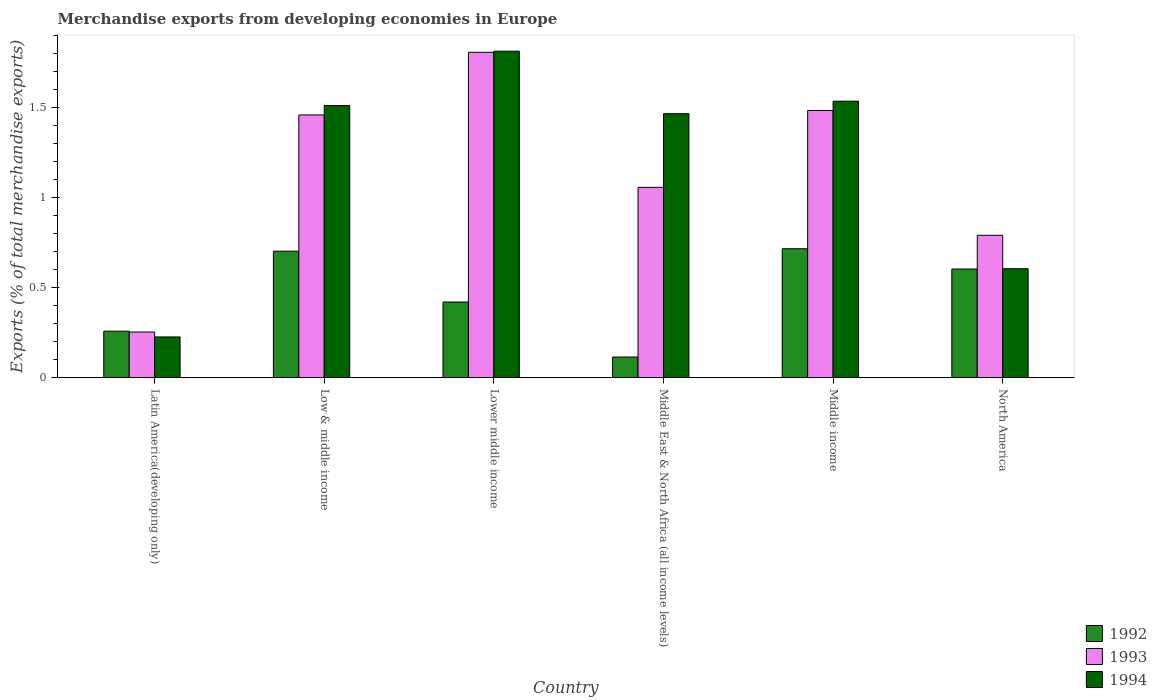How many groups of bars are there?
Keep it short and to the point. 6. Are the number of bars per tick equal to the number of legend labels?
Ensure brevity in your answer.  Yes. How many bars are there on the 2nd tick from the left?
Your answer should be very brief. 3. How many bars are there on the 6th tick from the right?
Your answer should be very brief. 3. What is the label of the 2nd group of bars from the left?
Provide a succinct answer. Low & middle income. In how many cases, is the number of bars for a given country not equal to the number of legend labels?
Offer a very short reply. 0. What is the percentage of total merchandise exports in 1992 in Middle East & North Africa (all income levels)?
Offer a terse response. 0.11. Across all countries, what is the maximum percentage of total merchandise exports in 1994?
Give a very brief answer. 1.81. Across all countries, what is the minimum percentage of total merchandise exports in 1992?
Your answer should be very brief. 0.11. In which country was the percentage of total merchandise exports in 1994 maximum?
Your answer should be compact. Lower middle income. In which country was the percentage of total merchandise exports in 1993 minimum?
Keep it short and to the point. Latin America(developing only). What is the total percentage of total merchandise exports in 1992 in the graph?
Provide a short and direct response. 2.82. What is the difference between the percentage of total merchandise exports in 1992 in Latin America(developing only) and that in Lower middle income?
Provide a succinct answer. -0.16. What is the difference between the percentage of total merchandise exports in 1994 in North America and the percentage of total merchandise exports in 1993 in Lower middle income?
Offer a terse response. -1.2. What is the average percentage of total merchandise exports in 1994 per country?
Your answer should be very brief. 1.19. What is the difference between the percentage of total merchandise exports of/in 1994 and percentage of total merchandise exports of/in 1993 in Latin America(developing only)?
Ensure brevity in your answer.  -0.03. What is the ratio of the percentage of total merchandise exports in 1993 in Low & middle income to that in Middle income?
Ensure brevity in your answer.  0.98. Is the percentage of total merchandise exports in 1993 in Latin America(developing only) less than that in North America?
Offer a terse response. Yes. What is the difference between the highest and the second highest percentage of total merchandise exports in 1992?
Provide a succinct answer. 0.01. What is the difference between the highest and the lowest percentage of total merchandise exports in 1994?
Keep it short and to the point. 1.59. In how many countries, is the percentage of total merchandise exports in 1993 greater than the average percentage of total merchandise exports in 1993 taken over all countries?
Offer a terse response. 3. What does the 1st bar from the right in Low & middle income represents?
Your answer should be compact. 1994. Is it the case that in every country, the sum of the percentage of total merchandise exports in 1994 and percentage of total merchandise exports in 1992 is greater than the percentage of total merchandise exports in 1993?
Your response must be concise. Yes. What is the difference between two consecutive major ticks on the Y-axis?
Your answer should be compact. 0.5. Are the values on the major ticks of Y-axis written in scientific E-notation?
Offer a terse response. No. Does the graph contain any zero values?
Make the answer very short. No. Does the graph contain grids?
Ensure brevity in your answer.  No. How many legend labels are there?
Give a very brief answer. 3. How are the legend labels stacked?
Ensure brevity in your answer.  Vertical. What is the title of the graph?
Give a very brief answer. Merchandise exports from developing economies in Europe. Does "2000" appear as one of the legend labels in the graph?
Give a very brief answer. No. What is the label or title of the Y-axis?
Offer a terse response. Exports (% of total merchandise exports). What is the Exports (% of total merchandise exports) of 1992 in Latin America(developing only)?
Your answer should be very brief. 0.26. What is the Exports (% of total merchandise exports) of 1993 in Latin America(developing only)?
Keep it short and to the point. 0.25. What is the Exports (% of total merchandise exports) in 1994 in Latin America(developing only)?
Your answer should be very brief. 0.23. What is the Exports (% of total merchandise exports) in 1992 in Low & middle income?
Make the answer very short. 0.7. What is the Exports (% of total merchandise exports) of 1993 in Low & middle income?
Provide a short and direct response. 1.46. What is the Exports (% of total merchandise exports) in 1994 in Low & middle income?
Your response must be concise. 1.51. What is the Exports (% of total merchandise exports) of 1992 in Lower middle income?
Offer a very short reply. 0.42. What is the Exports (% of total merchandise exports) in 1993 in Lower middle income?
Ensure brevity in your answer.  1.81. What is the Exports (% of total merchandise exports) in 1994 in Lower middle income?
Offer a terse response. 1.81. What is the Exports (% of total merchandise exports) in 1992 in Middle East & North Africa (all income levels)?
Ensure brevity in your answer.  0.11. What is the Exports (% of total merchandise exports) in 1993 in Middle East & North Africa (all income levels)?
Offer a terse response. 1.06. What is the Exports (% of total merchandise exports) in 1994 in Middle East & North Africa (all income levels)?
Give a very brief answer. 1.47. What is the Exports (% of total merchandise exports) of 1992 in Middle income?
Your response must be concise. 0.72. What is the Exports (% of total merchandise exports) in 1993 in Middle income?
Keep it short and to the point. 1.48. What is the Exports (% of total merchandise exports) in 1994 in Middle income?
Offer a terse response. 1.54. What is the Exports (% of total merchandise exports) of 1992 in North America?
Ensure brevity in your answer.  0.6. What is the Exports (% of total merchandise exports) in 1993 in North America?
Ensure brevity in your answer.  0.79. What is the Exports (% of total merchandise exports) in 1994 in North America?
Make the answer very short. 0.61. Across all countries, what is the maximum Exports (% of total merchandise exports) of 1992?
Your response must be concise. 0.72. Across all countries, what is the maximum Exports (% of total merchandise exports) of 1993?
Keep it short and to the point. 1.81. Across all countries, what is the maximum Exports (% of total merchandise exports) of 1994?
Ensure brevity in your answer.  1.81. Across all countries, what is the minimum Exports (% of total merchandise exports) in 1992?
Make the answer very short. 0.11. Across all countries, what is the minimum Exports (% of total merchandise exports) of 1993?
Make the answer very short. 0.25. Across all countries, what is the minimum Exports (% of total merchandise exports) of 1994?
Your response must be concise. 0.23. What is the total Exports (% of total merchandise exports) of 1992 in the graph?
Your response must be concise. 2.82. What is the total Exports (% of total merchandise exports) in 1993 in the graph?
Provide a short and direct response. 6.86. What is the total Exports (% of total merchandise exports) in 1994 in the graph?
Provide a short and direct response. 7.16. What is the difference between the Exports (% of total merchandise exports) of 1992 in Latin America(developing only) and that in Low & middle income?
Your answer should be very brief. -0.44. What is the difference between the Exports (% of total merchandise exports) of 1993 in Latin America(developing only) and that in Low & middle income?
Your answer should be very brief. -1.21. What is the difference between the Exports (% of total merchandise exports) in 1994 in Latin America(developing only) and that in Low & middle income?
Your answer should be compact. -1.29. What is the difference between the Exports (% of total merchandise exports) of 1992 in Latin America(developing only) and that in Lower middle income?
Offer a very short reply. -0.16. What is the difference between the Exports (% of total merchandise exports) in 1993 in Latin America(developing only) and that in Lower middle income?
Provide a short and direct response. -1.55. What is the difference between the Exports (% of total merchandise exports) in 1994 in Latin America(developing only) and that in Lower middle income?
Your response must be concise. -1.59. What is the difference between the Exports (% of total merchandise exports) of 1992 in Latin America(developing only) and that in Middle East & North Africa (all income levels)?
Your answer should be compact. 0.14. What is the difference between the Exports (% of total merchandise exports) in 1993 in Latin America(developing only) and that in Middle East & North Africa (all income levels)?
Offer a terse response. -0.8. What is the difference between the Exports (% of total merchandise exports) in 1994 in Latin America(developing only) and that in Middle East & North Africa (all income levels)?
Your answer should be very brief. -1.24. What is the difference between the Exports (% of total merchandise exports) of 1992 in Latin America(developing only) and that in Middle income?
Your answer should be very brief. -0.46. What is the difference between the Exports (% of total merchandise exports) in 1993 in Latin America(developing only) and that in Middle income?
Offer a very short reply. -1.23. What is the difference between the Exports (% of total merchandise exports) of 1994 in Latin America(developing only) and that in Middle income?
Your answer should be very brief. -1.31. What is the difference between the Exports (% of total merchandise exports) of 1992 in Latin America(developing only) and that in North America?
Ensure brevity in your answer.  -0.35. What is the difference between the Exports (% of total merchandise exports) of 1993 in Latin America(developing only) and that in North America?
Keep it short and to the point. -0.54. What is the difference between the Exports (% of total merchandise exports) of 1994 in Latin America(developing only) and that in North America?
Your answer should be very brief. -0.38. What is the difference between the Exports (% of total merchandise exports) of 1992 in Low & middle income and that in Lower middle income?
Offer a very short reply. 0.28. What is the difference between the Exports (% of total merchandise exports) in 1993 in Low & middle income and that in Lower middle income?
Provide a short and direct response. -0.35. What is the difference between the Exports (% of total merchandise exports) of 1994 in Low & middle income and that in Lower middle income?
Keep it short and to the point. -0.3. What is the difference between the Exports (% of total merchandise exports) of 1992 in Low & middle income and that in Middle East & North Africa (all income levels)?
Your answer should be very brief. 0.59. What is the difference between the Exports (% of total merchandise exports) of 1993 in Low & middle income and that in Middle East & North Africa (all income levels)?
Keep it short and to the point. 0.4. What is the difference between the Exports (% of total merchandise exports) in 1994 in Low & middle income and that in Middle East & North Africa (all income levels)?
Ensure brevity in your answer.  0.05. What is the difference between the Exports (% of total merchandise exports) of 1992 in Low & middle income and that in Middle income?
Your answer should be very brief. -0.01. What is the difference between the Exports (% of total merchandise exports) in 1993 in Low & middle income and that in Middle income?
Keep it short and to the point. -0.02. What is the difference between the Exports (% of total merchandise exports) of 1994 in Low & middle income and that in Middle income?
Make the answer very short. -0.02. What is the difference between the Exports (% of total merchandise exports) of 1992 in Low & middle income and that in North America?
Keep it short and to the point. 0.1. What is the difference between the Exports (% of total merchandise exports) of 1993 in Low & middle income and that in North America?
Your answer should be compact. 0.67. What is the difference between the Exports (% of total merchandise exports) of 1994 in Low & middle income and that in North America?
Give a very brief answer. 0.91. What is the difference between the Exports (% of total merchandise exports) in 1992 in Lower middle income and that in Middle East & North Africa (all income levels)?
Provide a succinct answer. 0.31. What is the difference between the Exports (% of total merchandise exports) in 1993 in Lower middle income and that in Middle East & North Africa (all income levels)?
Keep it short and to the point. 0.75. What is the difference between the Exports (% of total merchandise exports) of 1994 in Lower middle income and that in Middle East & North Africa (all income levels)?
Provide a short and direct response. 0.35. What is the difference between the Exports (% of total merchandise exports) of 1992 in Lower middle income and that in Middle income?
Make the answer very short. -0.3. What is the difference between the Exports (% of total merchandise exports) in 1993 in Lower middle income and that in Middle income?
Keep it short and to the point. 0.32. What is the difference between the Exports (% of total merchandise exports) in 1994 in Lower middle income and that in Middle income?
Make the answer very short. 0.28. What is the difference between the Exports (% of total merchandise exports) in 1992 in Lower middle income and that in North America?
Your answer should be very brief. -0.18. What is the difference between the Exports (% of total merchandise exports) of 1993 in Lower middle income and that in North America?
Offer a very short reply. 1.02. What is the difference between the Exports (% of total merchandise exports) of 1994 in Lower middle income and that in North America?
Provide a succinct answer. 1.21. What is the difference between the Exports (% of total merchandise exports) in 1992 in Middle East & North Africa (all income levels) and that in Middle income?
Your response must be concise. -0.6. What is the difference between the Exports (% of total merchandise exports) of 1993 in Middle East & North Africa (all income levels) and that in Middle income?
Offer a very short reply. -0.43. What is the difference between the Exports (% of total merchandise exports) in 1994 in Middle East & North Africa (all income levels) and that in Middle income?
Keep it short and to the point. -0.07. What is the difference between the Exports (% of total merchandise exports) in 1992 in Middle East & North Africa (all income levels) and that in North America?
Provide a succinct answer. -0.49. What is the difference between the Exports (% of total merchandise exports) of 1993 in Middle East & North Africa (all income levels) and that in North America?
Provide a short and direct response. 0.27. What is the difference between the Exports (% of total merchandise exports) in 1994 in Middle East & North Africa (all income levels) and that in North America?
Make the answer very short. 0.86. What is the difference between the Exports (% of total merchandise exports) in 1992 in Middle income and that in North America?
Provide a succinct answer. 0.11. What is the difference between the Exports (% of total merchandise exports) in 1993 in Middle income and that in North America?
Your answer should be very brief. 0.69. What is the difference between the Exports (% of total merchandise exports) of 1994 in Middle income and that in North America?
Keep it short and to the point. 0.93. What is the difference between the Exports (% of total merchandise exports) in 1992 in Latin America(developing only) and the Exports (% of total merchandise exports) in 1993 in Low & middle income?
Offer a terse response. -1.2. What is the difference between the Exports (% of total merchandise exports) in 1992 in Latin America(developing only) and the Exports (% of total merchandise exports) in 1994 in Low & middle income?
Your answer should be very brief. -1.25. What is the difference between the Exports (% of total merchandise exports) of 1993 in Latin America(developing only) and the Exports (% of total merchandise exports) of 1994 in Low & middle income?
Give a very brief answer. -1.26. What is the difference between the Exports (% of total merchandise exports) of 1992 in Latin America(developing only) and the Exports (% of total merchandise exports) of 1993 in Lower middle income?
Offer a very short reply. -1.55. What is the difference between the Exports (% of total merchandise exports) of 1992 in Latin America(developing only) and the Exports (% of total merchandise exports) of 1994 in Lower middle income?
Keep it short and to the point. -1.56. What is the difference between the Exports (% of total merchandise exports) of 1993 in Latin America(developing only) and the Exports (% of total merchandise exports) of 1994 in Lower middle income?
Offer a very short reply. -1.56. What is the difference between the Exports (% of total merchandise exports) of 1992 in Latin America(developing only) and the Exports (% of total merchandise exports) of 1993 in Middle East & North Africa (all income levels)?
Provide a short and direct response. -0.8. What is the difference between the Exports (% of total merchandise exports) in 1992 in Latin America(developing only) and the Exports (% of total merchandise exports) in 1994 in Middle East & North Africa (all income levels)?
Keep it short and to the point. -1.21. What is the difference between the Exports (% of total merchandise exports) in 1993 in Latin America(developing only) and the Exports (% of total merchandise exports) in 1994 in Middle East & North Africa (all income levels)?
Your answer should be very brief. -1.21. What is the difference between the Exports (% of total merchandise exports) in 1992 in Latin America(developing only) and the Exports (% of total merchandise exports) in 1993 in Middle income?
Give a very brief answer. -1.23. What is the difference between the Exports (% of total merchandise exports) in 1992 in Latin America(developing only) and the Exports (% of total merchandise exports) in 1994 in Middle income?
Your answer should be very brief. -1.28. What is the difference between the Exports (% of total merchandise exports) of 1993 in Latin America(developing only) and the Exports (% of total merchandise exports) of 1994 in Middle income?
Your answer should be compact. -1.28. What is the difference between the Exports (% of total merchandise exports) in 1992 in Latin America(developing only) and the Exports (% of total merchandise exports) in 1993 in North America?
Make the answer very short. -0.53. What is the difference between the Exports (% of total merchandise exports) of 1992 in Latin America(developing only) and the Exports (% of total merchandise exports) of 1994 in North America?
Your answer should be very brief. -0.35. What is the difference between the Exports (% of total merchandise exports) in 1993 in Latin America(developing only) and the Exports (% of total merchandise exports) in 1994 in North America?
Make the answer very short. -0.35. What is the difference between the Exports (% of total merchandise exports) of 1992 in Low & middle income and the Exports (% of total merchandise exports) of 1993 in Lower middle income?
Ensure brevity in your answer.  -1.11. What is the difference between the Exports (% of total merchandise exports) of 1992 in Low & middle income and the Exports (% of total merchandise exports) of 1994 in Lower middle income?
Ensure brevity in your answer.  -1.11. What is the difference between the Exports (% of total merchandise exports) in 1993 in Low & middle income and the Exports (% of total merchandise exports) in 1994 in Lower middle income?
Give a very brief answer. -0.35. What is the difference between the Exports (% of total merchandise exports) in 1992 in Low & middle income and the Exports (% of total merchandise exports) in 1993 in Middle East & North Africa (all income levels)?
Your answer should be compact. -0.35. What is the difference between the Exports (% of total merchandise exports) of 1992 in Low & middle income and the Exports (% of total merchandise exports) of 1994 in Middle East & North Africa (all income levels)?
Provide a short and direct response. -0.76. What is the difference between the Exports (% of total merchandise exports) of 1993 in Low & middle income and the Exports (% of total merchandise exports) of 1994 in Middle East & North Africa (all income levels)?
Provide a succinct answer. -0.01. What is the difference between the Exports (% of total merchandise exports) in 1992 in Low & middle income and the Exports (% of total merchandise exports) in 1993 in Middle income?
Offer a very short reply. -0.78. What is the difference between the Exports (% of total merchandise exports) of 1992 in Low & middle income and the Exports (% of total merchandise exports) of 1994 in Middle income?
Keep it short and to the point. -0.83. What is the difference between the Exports (% of total merchandise exports) in 1993 in Low & middle income and the Exports (% of total merchandise exports) in 1994 in Middle income?
Offer a very short reply. -0.08. What is the difference between the Exports (% of total merchandise exports) in 1992 in Low & middle income and the Exports (% of total merchandise exports) in 1993 in North America?
Provide a short and direct response. -0.09. What is the difference between the Exports (% of total merchandise exports) of 1992 in Low & middle income and the Exports (% of total merchandise exports) of 1994 in North America?
Give a very brief answer. 0.1. What is the difference between the Exports (% of total merchandise exports) in 1993 in Low & middle income and the Exports (% of total merchandise exports) in 1994 in North America?
Your response must be concise. 0.85. What is the difference between the Exports (% of total merchandise exports) in 1992 in Lower middle income and the Exports (% of total merchandise exports) in 1993 in Middle East & North Africa (all income levels)?
Offer a terse response. -0.64. What is the difference between the Exports (% of total merchandise exports) in 1992 in Lower middle income and the Exports (% of total merchandise exports) in 1994 in Middle East & North Africa (all income levels)?
Your answer should be very brief. -1.05. What is the difference between the Exports (% of total merchandise exports) in 1993 in Lower middle income and the Exports (% of total merchandise exports) in 1994 in Middle East & North Africa (all income levels)?
Offer a very short reply. 0.34. What is the difference between the Exports (% of total merchandise exports) in 1992 in Lower middle income and the Exports (% of total merchandise exports) in 1993 in Middle income?
Provide a short and direct response. -1.06. What is the difference between the Exports (% of total merchandise exports) of 1992 in Lower middle income and the Exports (% of total merchandise exports) of 1994 in Middle income?
Offer a terse response. -1.12. What is the difference between the Exports (% of total merchandise exports) in 1993 in Lower middle income and the Exports (% of total merchandise exports) in 1994 in Middle income?
Your answer should be very brief. 0.27. What is the difference between the Exports (% of total merchandise exports) of 1992 in Lower middle income and the Exports (% of total merchandise exports) of 1993 in North America?
Make the answer very short. -0.37. What is the difference between the Exports (% of total merchandise exports) of 1992 in Lower middle income and the Exports (% of total merchandise exports) of 1994 in North America?
Provide a short and direct response. -0.18. What is the difference between the Exports (% of total merchandise exports) in 1993 in Lower middle income and the Exports (% of total merchandise exports) in 1994 in North America?
Offer a very short reply. 1.2. What is the difference between the Exports (% of total merchandise exports) in 1992 in Middle East & North Africa (all income levels) and the Exports (% of total merchandise exports) in 1993 in Middle income?
Provide a short and direct response. -1.37. What is the difference between the Exports (% of total merchandise exports) of 1992 in Middle East & North Africa (all income levels) and the Exports (% of total merchandise exports) of 1994 in Middle income?
Ensure brevity in your answer.  -1.42. What is the difference between the Exports (% of total merchandise exports) of 1993 in Middle East & North Africa (all income levels) and the Exports (% of total merchandise exports) of 1994 in Middle income?
Your answer should be compact. -0.48. What is the difference between the Exports (% of total merchandise exports) in 1992 in Middle East & North Africa (all income levels) and the Exports (% of total merchandise exports) in 1993 in North America?
Your answer should be compact. -0.68. What is the difference between the Exports (% of total merchandise exports) in 1992 in Middle East & North Africa (all income levels) and the Exports (% of total merchandise exports) in 1994 in North America?
Give a very brief answer. -0.49. What is the difference between the Exports (% of total merchandise exports) in 1993 in Middle East & North Africa (all income levels) and the Exports (% of total merchandise exports) in 1994 in North America?
Make the answer very short. 0.45. What is the difference between the Exports (% of total merchandise exports) in 1992 in Middle income and the Exports (% of total merchandise exports) in 1993 in North America?
Offer a very short reply. -0.07. What is the difference between the Exports (% of total merchandise exports) of 1993 in Middle income and the Exports (% of total merchandise exports) of 1994 in North America?
Provide a short and direct response. 0.88. What is the average Exports (% of total merchandise exports) of 1992 per country?
Give a very brief answer. 0.47. What is the average Exports (% of total merchandise exports) of 1993 per country?
Offer a very short reply. 1.14. What is the average Exports (% of total merchandise exports) of 1994 per country?
Ensure brevity in your answer.  1.19. What is the difference between the Exports (% of total merchandise exports) in 1992 and Exports (% of total merchandise exports) in 1993 in Latin America(developing only)?
Make the answer very short. 0. What is the difference between the Exports (% of total merchandise exports) in 1992 and Exports (% of total merchandise exports) in 1994 in Latin America(developing only)?
Your answer should be compact. 0.03. What is the difference between the Exports (% of total merchandise exports) in 1993 and Exports (% of total merchandise exports) in 1994 in Latin America(developing only)?
Give a very brief answer. 0.03. What is the difference between the Exports (% of total merchandise exports) of 1992 and Exports (% of total merchandise exports) of 1993 in Low & middle income?
Give a very brief answer. -0.76. What is the difference between the Exports (% of total merchandise exports) in 1992 and Exports (% of total merchandise exports) in 1994 in Low & middle income?
Your answer should be very brief. -0.81. What is the difference between the Exports (% of total merchandise exports) of 1993 and Exports (% of total merchandise exports) of 1994 in Low & middle income?
Offer a terse response. -0.05. What is the difference between the Exports (% of total merchandise exports) in 1992 and Exports (% of total merchandise exports) in 1993 in Lower middle income?
Give a very brief answer. -1.39. What is the difference between the Exports (% of total merchandise exports) of 1992 and Exports (% of total merchandise exports) of 1994 in Lower middle income?
Provide a succinct answer. -1.39. What is the difference between the Exports (% of total merchandise exports) of 1993 and Exports (% of total merchandise exports) of 1994 in Lower middle income?
Provide a succinct answer. -0.01. What is the difference between the Exports (% of total merchandise exports) in 1992 and Exports (% of total merchandise exports) in 1993 in Middle East & North Africa (all income levels)?
Your answer should be very brief. -0.94. What is the difference between the Exports (% of total merchandise exports) of 1992 and Exports (% of total merchandise exports) of 1994 in Middle East & North Africa (all income levels)?
Provide a succinct answer. -1.35. What is the difference between the Exports (% of total merchandise exports) in 1993 and Exports (% of total merchandise exports) in 1994 in Middle East & North Africa (all income levels)?
Offer a very short reply. -0.41. What is the difference between the Exports (% of total merchandise exports) in 1992 and Exports (% of total merchandise exports) in 1993 in Middle income?
Your answer should be very brief. -0.77. What is the difference between the Exports (% of total merchandise exports) of 1992 and Exports (% of total merchandise exports) of 1994 in Middle income?
Offer a very short reply. -0.82. What is the difference between the Exports (% of total merchandise exports) in 1993 and Exports (% of total merchandise exports) in 1994 in Middle income?
Offer a very short reply. -0.05. What is the difference between the Exports (% of total merchandise exports) of 1992 and Exports (% of total merchandise exports) of 1993 in North America?
Keep it short and to the point. -0.19. What is the difference between the Exports (% of total merchandise exports) of 1992 and Exports (% of total merchandise exports) of 1994 in North America?
Give a very brief answer. -0. What is the difference between the Exports (% of total merchandise exports) in 1993 and Exports (% of total merchandise exports) in 1994 in North America?
Ensure brevity in your answer.  0.19. What is the ratio of the Exports (% of total merchandise exports) in 1992 in Latin America(developing only) to that in Low & middle income?
Offer a very short reply. 0.37. What is the ratio of the Exports (% of total merchandise exports) of 1993 in Latin America(developing only) to that in Low & middle income?
Your answer should be compact. 0.17. What is the ratio of the Exports (% of total merchandise exports) of 1994 in Latin America(developing only) to that in Low & middle income?
Your response must be concise. 0.15. What is the ratio of the Exports (% of total merchandise exports) in 1992 in Latin America(developing only) to that in Lower middle income?
Offer a terse response. 0.61. What is the ratio of the Exports (% of total merchandise exports) in 1993 in Latin America(developing only) to that in Lower middle income?
Offer a very short reply. 0.14. What is the ratio of the Exports (% of total merchandise exports) of 1994 in Latin America(developing only) to that in Lower middle income?
Your answer should be very brief. 0.12. What is the ratio of the Exports (% of total merchandise exports) of 1992 in Latin America(developing only) to that in Middle East & North Africa (all income levels)?
Give a very brief answer. 2.25. What is the ratio of the Exports (% of total merchandise exports) in 1993 in Latin America(developing only) to that in Middle East & North Africa (all income levels)?
Provide a short and direct response. 0.24. What is the ratio of the Exports (% of total merchandise exports) of 1994 in Latin America(developing only) to that in Middle East & North Africa (all income levels)?
Give a very brief answer. 0.15. What is the ratio of the Exports (% of total merchandise exports) of 1992 in Latin America(developing only) to that in Middle income?
Make the answer very short. 0.36. What is the ratio of the Exports (% of total merchandise exports) of 1993 in Latin America(developing only) to that in Middle income?
Offer a very short reply. 0.17. What is the ratio of the Exports (% of total merchandise exports) in 1994 in Latin America(developing only) to that in Middle income?
Ensure brevity in your answer.  0.15. What is the ratio of the Exports (% of total merchandise exports) in 1992 in Latin America(developing only) to that in North America?
Your answer should be compact. 0.43. What is the ratio of the Exports (% of total merchandise exports) of 1993 in Latin America(developing only) to that in North America?
Make the answer very short. 0.32. What is the ratio of the Exports (% of total merchandise exports) in 1994 in Latin America(developing only) to that in North America?
Your answer should be compact. 0.37. What is the ratio of the Exports (% of total merchandise exports) of 1992 in Low & middle income to that in Lower middle income?
Provide a succinct answer. 1.67. What is the ratio of the Exports (% of total merchandise exports) in 1993 in Low & middle income to that in Lower middle income?
Offer a very short reply. 0.81. What is the ratio of the Exports (% of total merchandise exports) in 1994 in Low & middle income to that in Lower middle income?
Offer a terse response. 0.83. What is the ratio of the Exports (% of total merchandise exports) in 1992 in Low & middle income to that in Middle East & North Africa (all income levels)?
Provide a short and direct response. 6.13. What is the ratio of the Exports (% of total merchandise exports) of 1993 in Low & middle income to that in Middle East & North Africa (all income levels)?
Provide a succinct answer. 1.38. What is the ratio of the Exports (% of total merchandise exports) in 1994 in Low & middle income to that in Middle East & North Africa (all income levels)?
Offer a very short reply. 1.03. What is the ratio of the Exports (% of total merchandise exports) in 1992 in Low & middle income to that in Middle income?
Your answer should be very brief. 0.98. What is the ratio of the Exports (% of total merchandise exports) in 1993 in Low & middle income to that in Middle income?
Keep it short and to the point. 0.98. What is the ratio of the Exports (% of total merchandise exports) of 1994 in Low & middle income to that in Middle income?
Make the answer very short. 0.98. What is the ratio of the Exports (% of total merchandise exports) of 1992 in Low & middle income to that in North America?
Ensure brevity in your answer.  1.16. What is the ratio of the Exports (% of total merchandise exports) in 1993 in Low & middle income to that in North America?
Provide a short and direct response. 1.85. What is the ratio of the Exports (% of total merchandise exports) in 1994 in Low & middle income to that in North America?
Make the answer very short. 2.5. What is the ratio of the Exports (% of total merchandise exports) in 1992 in Lower middle income to that in Middle East & North Africa (all income levels)?
Your answer should be very brief. 3.67. What is the ratio of the Exports (% of total merchandise exports) in 1993 in Lower middle income to that in Middle East & North Africa (all income levels)?
Provide a short and direct response. 1.71. What is the ratio of the Exports (% of total merchandise exports) of 1994 in Lower middle income to that in Middle East & North Africa (all income levels)?
Your answer should be very brief. 1.24. What is the ratio of the Exports (% of total merchandise exports) in 1992 in Lower middle income to that in Middle income?
Give a very brief answer. 0.59. What is the ratio of the Exports (% of total merchandise exports) in 1993 in Lower middle income to that in Middle income?
Your answer should be compact. 1.22. What is the ratio of the Exports (% of total merchandise exports) in 1994 in Lower middle income to that in Middle income?
Provide a short and direct response. 1.18. What is the ratio of the Exports (% of total merchandise exports) of 1992 in Lower middle income to that in North America?
Provide a succinct answer. 0.7. What is the ratio of the Exports (% of total merchandise exports) of 1993 in Lower middle income to that in North America?
Your answer should be compact. 2.29. What is the ratio of the Exports (% of total merchandise exports) in 1994 in Lower middle income to that in North America?
Ensure brevity in your answer.  3. What is the ratio of the Exports (% of total merchandise exports) in 1992 in Middle East & North Africa (all income levels) to that in Middle income?
Your answer should be very brief. 0.16. What is the ratio of the Exports (% of total merchandise exports) in 1993 in Middle East & North Africa (all income levels) to that in Middle income?
Your answer should be compact. 0.71. What is the ratio of the Exports (% of total merchandise exports) in 1994 in Middle East & North Africa (all income levels) to that in Middle income?
Offer a very short reply. 0.95. What is the ratio of the Exports (% of total merchandise exports) of 1992 in Middle East & North Africa (all income levels) to that in North America?
Offer a very short reply. 0.19. What is the ratio of the Exports (% of total merchandise exports) of 1993 in Middle East & North Africa (all income levels) to that in North America?
Your answer should be very brief. 1.34. What is the ratio of the Exports (% of total merchandise exports) in 1994 in Middle East & North Africa (all income levels) to that in North America?
Give a very brief answer. 2.42. What is the ratio of the Exports (% of total merchandise exports) in 1992 in Middle income to that in North America?
Keep it short and to the point. 1.19. What is the ratio of the Exports (% of total merchandise exports) of 1993 in Middle income to that in North America?
Provide a short and direct response. 1.88. What is the ratio of the Exports (% of total merchandise exports) in 1994 in Middle income to that in North America?
Your answer should be very brief. 2.54. What is the difference between the highest and the second highest Exports (% of total merchandise exports) in 1992?
Offer a very short reply. 0.01. What is the difference between the highest and the second highest Exports (% of total merchandise exports) of 1993?
Offer a terse response. 0.32. What is the difference between the highest and the second highest Exports (% of total merchandise exports) of 1994?
Give a very brief answer. 0.28. What is the difference between the highest and the lowest Exports (% of total merchandise exports) in 1992?
Offer a very short reply. 0.6. What is the difference between the highest and the lowest Exports (% of total merchandise exports) of 1993?
Make the answer very short. 1.55. What is the difference between the highest and the lowest Exports (% of total merchandise exports) of 1994?
Make the answer very short. 1.59. 